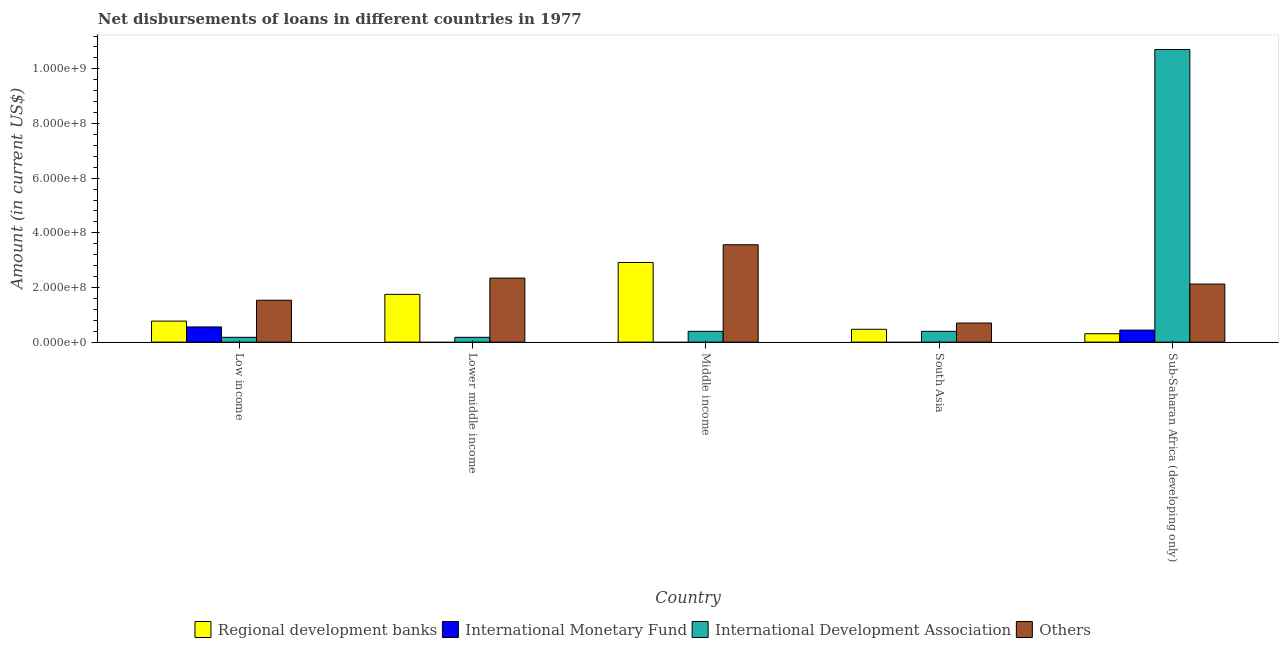How many groups of bars are there?
Provide a succinct answer. 5. Are the number of bars on each tick of the X-axis equal?
Ensure brevity in your answer.  No. What is the label of the 2nd group of bars from the left?
Keep it short and to the point. Lower middle income. What is the amount of loan disimbursed by regional development banks in South Asia?
Offer a very short reply. 4.70e+07. Across all countries, what is the maximum amount of loan disimbursed by international development association?
Offer a terse response. 1.07e+09. What is the total amount of loan disimbursed by regional development banks in the graph?
Offer a terse response. 6.21e+08. What is the difference between the amount of loan disimbursed by regional development banks in Lower middle income and that in South Asia?
Your answer should be compact. 1.28e+08. What is the difference between the amount of loan disimbursed by regional development banks in Lower middle income and the amount of loan disimbursed by international monetary fund in South Asia?
Provide a succinct answer. 1.75e+08. What is the average amount of loan disimbursed by regional development banks per country?
Your response must be concise. 1.24e+08. What is the difference between the amount of loan disimbursed by international development association and amount of loan disimbursed by other organisations in Low income?
Make the answer very short. -1.36e+08. In how many countries, is the amount of loan disimbursed by international development association greater than 1040000000 US$?
Your answer should be very brief. 1. What is the ratio of the amount of loan disimbursed by regional development banks in Lower middle income to that in South Asia?
Make the answer very short. 3.72. Is the amount of loan disimbursed by international development association in Middle income less than that in Sub-Saharan Africa (developing only)?
Provide a short and direct response. Yes. What is the difference between the highest and the second highest amount of loan disimbursed by international development association?
Ensure brevity in your answer.  1.03e+09. What is the difference between the highest and the lowest amount of loan disimbursed by regional development banks?
Make the answer very short. 2.61e+08. Is it the case that in every country, the sum of the amount of loan disimbursed by international development association and amount of loan disimbursed by other organisations is greater than the sum of amount of loan disimbursed by international monetary fund and amount of loan disimbursed by regional development banks?
Keep it short and to the point. No. How many countries are there in the graph?
Offer a terse response. 5. What is the difference between two consecutive major ticks on the Y-axis?
Your answer should be compact. 2.00e+08. Where does the legend appear in the graph?
Your answer should be compact. Bottom center. How many legend labels are there?
Give a very brief answer. 4. What is the title of the graph?
Keep it short and to the point. Net disbursements of loans in different countries in 1977. Does "Coal" appear as one of the legend labels in the graph?
Give a very brief answer. No. What is the Amount (in current US$) in Regional development banks in Low income?
Offer a very short reply. 7.70e+07. What is the Amount (in current US$) of International Monetary Fund in Low income?
Ensure brevity in your answer.  5.57e+07. What is the Amount (in current US$) in International Development Association in Low income?
Ensure brevity in your answer.  1.77e+07. What is the Amount (in current US$) of Others in Low income?
Keep it short and to the point. 1.53e+08. What is the Amount (in current US$) in Regional development banks in Lower middle income?
Your answer should be very brief. 1.75e+08. What is the Amount (in current US$) in International Monetary Fund in Lower middle income?
Your response must be concise. 0. What is the Amount (in current US$) in International Development Association in Lower middle income?
Offer a terse response. 1.77e+07. What is the Amount (in current US$) in Others in Lower middle income?
Ensure brevity in your answer.  2.34e+08. What is the Amount (in current US$) in Regional development banks in Middle income?
Provide a succinct answer. 2.91e+08. What is the Amount (in current US$) of International Development Association in Middle income?
Offer a very short reply. 3.96e+07. What is the Amount (in current US$) in Others in Middle income?
Your answer should be compact. 3.56e+08. What is the Amount (in current US$) of Regional development banks in South Asia?
Your answer should be very brief. 4.70e+07. What is the Amount (in current US$) of International Monetary Fund in South Asia?
Provide a succinct answer. 0. What is the Amount (in current US$) in International Development Association in South Asia?
Your answer should be very brief. 3.96e+07. What is the Amount (in current US$) of Others in South Asia?
Offer a very short reply. 6.99e+07. What is the Amount (in current US$) in Regional development banks in Sub-Saharan Africa (developing only)?
Provide a short and direct response. 3.08e+07. What is the Amount (in current US$) of International Monetary Fund in Sub-Saharan Africa (developing only)?
Your answer should be very brief. 4.41e+07. What is the Amount (in current US$) in International Development Association in Sub-Saharan Africa (developing only)?
Ensure brevity in your answer.  1.07e+09. What is the Amount (in current US$) in Others in Sub-Saharan Africa (developing only)?
Keep it short and to the point. 2.13e+08. Across all countries, what is the maximum Amount (in current US$) in Regional development banks?
Your answer should be compact. 2.91e+08. Across all countries, what is the maximum Amount (in current US$) in International Monetary Fund?
Offer a terse response. 5.57e+07. Across all countries, what is the maximum Amount (in current US$) in International Development Association?
Offer a terse response. 1.07e+09. Across all countries, what is the maximum Amount (in current US$) in Others?
Offer a terse response. 3.56e+08. Across all countries, what is the minimum Amount (in current US$) of Regional development banks?
Keep it short and to the point. 3.08e+07. Across all countries, what is the minimum Amount (in current US$) in International Development Association?
Give a very brief answer. 1.77e+07. Across all countries, what is the minimum Amount (in current US$) in Others?
Make the answer very short. 6.99e+07. What is the total Amount (in current US$) in Regional development banks in the graph?
Your response must be concise. 6.21e+08. What is the total Amount (in current US$) in International Monetary Fund in the graph?
Your answer should be very brief. 9.98e+07. What is the total Amount (in current US$) of International Development Association in the graph?
Offer a terse response. 1.19e+09. What is the total Amount (in current US$) in Others in the graph?
Offer a very short reply. 1.03e+09. What is the difference between the Amount (in current US$) in Regional development banks in Low income and that in Lower middle income?
Your response must be concise. -9.78e+07. What is the difference between the Amount (in current US$) of International Development Association in Low income and that in Lower middle income?
Offer a very short reply. 0. What is the difference between the Amount (in current US$) of Others in Low income and that in Lower middle income?
Offer a very short reply. -8.11e+07. What is the difference between the Amount (in current US$) of Regional development banks in Low income and that in Middle income?
Provide a succinct answer. -2.14e+08. What is the difference between the Amount (in current US$) of International Development Association in Low income and that in Middle income?
Your answer should be very brief. -2.19e+07. What is the difference between the Amount (in current US$) in Others in Low income and that in Middle income?
Provide a short and direct response. -2.03e+08. What is the difference between the Amount (in current US$) of Regional development banks in Low income and that in South Asia?
Ensure brevity in your answer.  3.00e+07. What is the difference between the Amount (in current US$) in International Development Association in Low income and that in South Asia?
Offer a very short reply. -2.19e+07. What is the difference between the Amount (in current US$) in Others in Low income and that in South Asia?
Your response must be concise. 8.34e+07. What is the difference between the Amount (in current US$) in Regional development banks in Low income and that in Sub-Saharan Africa (developing only)?
Give a very brief answer. 4.63e+07. What is the difference between the Amount (in current US$) in International Monetary Fund in Low income and that in Sub-Saharan Africa (developing only)?
Offer a very short reply. 1.16e+07. What is the difference between the Amount (in current US$) of International Development Association in Low income and that in Sub-Saharan Africa (developing only)?
Keep it short and to the point. -1.05e+09. What is the difference between the Amount (in current US$) in Others in Low income and that in Sub-Saharan Africa (developing only)?
Offer a terse response. -5.93e+07. What is the difference between the Amount (in current US$) of Regional development banks in Lower middle income and that in Middle income?
Your response must be concise. -1.17e+08. What is the difference between the Amount (in current US$) in International Development Association in Lower middle income and that in Middle income?
Your answer should be very brief. -2.19e+07. What is the difference between the Amount (in current US$) of Others in Lower middle income and that in Middle income?
Make the answer very short. -1.22e+08. What is the difference between the Amount (in current US$) in Regional development banks in Lower middle income and that in South Asia?
Provide a succinct answer. 1.28e+08. What is the difference between the Amount (in current US$) of International Development Association in Lower middle income and that in South Asia?
Provide a short and direct response. -2.19e+07. What is the difference between the Amount (in current US$) of Others in Lower middle income and that in South Asia?
Your answer should be compact. 1.65e+08. What is the difference between the Amount (in current US$) in Regional development banks in Lower middle income and that in Sub-Saharan Africa (developing only)?
Your answer should be very brief. 1.44e+08. What is the difference between the Amount (in current US$) in International Development Association in Lower middle income and that in Sub-Saharan Africa (developing only)?
Provide a succinct answer. -1.05e+09. What is the difference between the Amount (in current US$) in Others in Lower middle income and that in Sub-Saharan Africa (developing only)?
Keep it short and to the point. 2.18e+07. What is the difference between the Amount (in current US$) of Regional development banks in Middle income and that in South Asia?
Your answer should be compact. 2.44e+08. What is the difference between the Amount (in current US$) in Others in Middle income and that in South Asia?
Your answer should be compact. 2.86e+08. What is the difference between the Amount (in current US$) in Regional development banks in Middle income and that in Sub-Saharan Africa (developing only)?
Give a very brief answer. 2.61e+08. What is the difference between the Amount (in current US$) of International Development Association in Middle income and that in Sub-Saharan Africa (developing only)?
Ensure brevity in your answer.  -1.03e+09. What is the difference between the Amount (in current US$) of Others in Middle income and that in Sub-Saharan Africa (developing only)?
Provide a succinct answer. 1.44e+08. What is the difference between the Amount (in current US$) of Regional development banks in South Asia and that in Sub-Saharan Africa (developing only)?
Give a very brief answer. 1.63e+07. What is the difference between the Amount (in current US$) in International Development Association in South Asia and that in Sub-Saharan Africa (developing only)?
Offer a very short reply. -1.03e+09. What is the difference between the Amount (in current US$) of Others in South Asia and that in Sub-Saharan Africa (developing only)?
Your answer should be very brief. -1.43e+08. What is the difference between the Amount (in current US$) in Regional development banks in Low income and the Amount (in current US$) in International Development Association in Lower middle income?
Your answer should be compact. 5.93e+07. What is the difference between the Amount (in current US$) of Regional development banks in Low income and the Amount (in current US$) of Others in Lower middle income?
Offer a terse response. -1.57e+08. What is the difference between the Amount (in current US$) of International Monetary Fund in Low income and the Amount (in current US$) of International Development Association in Lower middle income?
Give a very brief answer. 3.80e+07. What is the difference between the Amount (in current US$) in International Monetary Fund in Low income and the Amount (in current US$) in Others in Lower middle income?
Keep it short and to the point. -1.79e+08. What is the difference between the Amount (in current US$) in International Development Association in Low income and the Amount (in current US$) in Others in Lower middle income?
Make the answer very short. -2.17e+08. What is the difference between the Amount (in current US$) of Regional development banks in Low income and the Amount (in current US$) of International Development Association in Middle income?
Ensure brevity in your answer.  3.75e+07. What is the difference between the Amount (in current US$) of Regional development banks in Low income and the Amount (in current US$) of Others in Middle income?
Ensure brevity in your answer.  -2.79e+08. What is the difference between the Amount (in current US$) in International Monetary Fund in Low income and the Amount (in current US$) in International Development Association in Middle income?
Your answer should be very brief. 1.61e+07. What is the difference between the Amount (in current US$) in International Monetary Fund in Low income and the Amount (in current US$) in Others in Middle income?
Ensure brevity in your answer.  -3.01e+08. What is the difference between the Amount (in current US$) of International Development Association in Low income and the Amount (in current US$) of Others in Middle income?
Your response must be concise. -3.39e+08. What is the difference between the Amount (in current US$) of Regional development banks in Low income and the Amount (in current US$) of International Development Association in South Asia?
Provide a succinct answer. 3.75e+07. What is the difference between the Amount (in current US$) of Regional development banks in Low income and the Amount (in current US$) of Others in South Asia?
Provide a short and direct response. 7.12e+06. What is the difference between the Amount (in current US$) of International Monetary Fund in Low income and the Amount (in current US$) of International Development Association in South Asia?
Make the answer very short. 1.61e+07. What is the difference between the Amount (in current US$) of International Monetary Fund in Low income and the Amount (in current US$) of Others in South Asia?
Keep it short and to the point. -1.42e+07. What is the difference between the Amount (in current US$) of International Development Association in Low income and the Amount (in current US$) of Others in South Asia?
Make the answer very short. -5.22e+07. What is the difference between the Amount (in current US$) of Regional development banks in Low income and the Amount (in current US$) of International Monetary Fund in Sub-Saharan Africa (developing only)?
Your answer should be compact. 3.29e+07. What is the difference between the Amount (in current US$) in Regional development banks in Low income and the Amount (in current US$) in International Development Association in Sub-Saharan Africa (developing only)?
Your answer should be compact. -9.94e+08. What is the difference between the Amount (in current US$) in Regional development banks in Low income and the Amount (in current US$) in Others in Sub-Saharan Africa (developing only)?
Offer a terse response. -1.36e+08. What is the difference between the Amount (in current US$) in International Monetary Fund in Low income and the Amount (in current US$) in International Development Association in Sub-Saharan Africa (developing only)?
Offer a very short reply. -1.02e+09. What is the difference between the Amount (in current US$) in International Monetary Fund in Low income and the Amount (in current US$) in Others in Sub-Saharan Africa (developing only)?
Make the answer very short. -1.57e+08. What is the difference between the Amount (in current US$) of International Development Association in Low income and the Amount (in current US$) of Others in Sub-Saharan Africa (developing only)?
Your response must be concise. -1.95e+08. What is the difference between the Amount (in current US$) of Regional development banks in Lower middle income and the Amount (in current US$) of International Development Association in Middle income?
Provide a short and direct response. 1.35e+08. What is the difference between the Amount (in current US$) in Regional development banks in Lower middle income and the Amount (in current US$) in Others in Middle income?
Give a very brief answer. -1.81e+08. What is the difference between the Amount (in current US$) in International Development Association in Lower middle income and the Amount (in current US$) in Others in Middle income?
Make the answer very short. -3.39e+08. What is the difference between the Amount (in current US$) in Regional development banks in Lower middle income and the Amount (in current US$) in International Development Association in South Asia?
Provide a short and direct response. 1.35e+08. What is the difference between the Amount (in current US$) in Regional development banks in Lower middle income and the Amount (in current US$) in Others in South Asia?
Make the answer very short. 1.05e+08. What is the difference between the Amount (in current US$) in International Development Association in Lower middle income and the Amount (in current US$) in Others in South Asia?
Provide a succinct answer. -5.22e+07. What is the difference between the Amount (in current US$) in Regional development banks in Lower middle income and the Amount (in current US$) in International Monetary Fund in Sub-Saharan Africa (developing only)?
Your response must be concise. 1.31e+08. What is the difference between the Amount (in current US$) of Regional development banks in Lower middle income and the Amount (in current US$) of International Development Association in Sub-Saharan Africa (developing only)?
Your answer should be very brief. -8.96e+08. What is the difference between the Amount (in current US$) in Regional development banks in Lower middle income and the Amount (in current US$) in Others in Sub-Saharan Africa (developing only)?
Ensure brevity in your answer.  -3.78e+07. What is the difference between the Amount (in current US$) of International Development Association in Lower middle income and the Amount (in current US$) of Others in Sub-Saharan Africa (developing only)?
Your answer should be compact. -1.95e+08. What is the difference between the Amount (in current US$) of Regional development banks in Middle income and the Amount (in current US$) of International Development Association in South Asia?
Ensure brevity in your answer.  2.52e+08. What is the difference between the Amount (in current US$) of Regional development banks in Middle income and the Amount (in current US$) of Others in South Asia?
Your answer should be compact. 2.22e+08. What is the difference between the Amount (in current US$) in International Development Association in Middle income and the Amount (in current US$) in Others in South Asia?
Your answer should be compact. -3.03e+07. What is the difference between the Amount (in current US$) in Regional development banks in Middle income and the Amount (in current US$) in International Monetary Fund in Sub-Saharan Africa (developing only)?
Your answer should be very brief. 2.47e+08. What is the difference between the Amount (in current US$) of Regional development banks in Middle income and the Amount (in current US$) of International Development Association in Sub-Saharan Africa (developing only)?
Provide a succinct answer. -7.79e+08. What is the difference between the Amount (in current US$) of Regional development banks in Middle income and the Amount (in current US$) of Others in Sub-Saharan Africa (developing only)?
Provide a short and direct response. 7.88e+07. What is the difference between the Amount (in current US$) of International Development Association in Middle income and the Amount (in current US$) of Others in Sub-Saharan Africa (developing only)?
Give a very brief answer. -1.73e+08. What is the difference between the Amount (in current US$) in Regional development banks in South Asia and the Amount (in current US$) in International Monetary Fund in Sub-Saharan Africa (developing only)?
Ensure brevity in your answer.  2.94e+06. What is the difference between the Amount (in current US$) in Regional development banks in South Asia and the Amount (in current US$) in International Development Association in Sub-Saharan Africa (developing only)?
Your response must be concise. -1.02e+09. What is the difference between the Amount (in current US$) of Regional development banks in South Asia and the Amount (in current US$) of Others in Sub-Saharan Africa (developing only)?
Your response must be concise. -1.66e+08. What is the difference between the Amount (in current US$) in International Development Association in South Asia and the Amount (in current US$) in Others in Sub-Saharan Africa (developing only)?
Your response must be concise. -1.73e+08. What is the average Amount (in current US$) in Regional development banks per country?
Your response must be concise. 1.24e+08. What is the average Amount (in current US$) in International Monetary Fund per country?
Keep it short and to the point. 2.00e+07. What is the average Amount (in current US$) in International Development Association per country?
Offer a very short reply. 2.37e+08. What is the average Amount (in current US$) in Others per country?
Provide a succinct answer. 2.05e+08. What is the difference between the Amount (in current US$) in Regional development banks and Amount (in current US$) in International Monetary Fund in Low income?
Ensure brevity in your answer.  2.13e+07. What is the difference between the Amount (in current US$) in Regional development banks and Amount (in current US$) in International Development Association in Low income?
Offer a very short reply. 5.93e+07. What is the difference between the Amount (in current US$) in Regional development banks and Amount (in current US$) in Others in Low income?
Your answer should be very brief. -7.63e+07. What is the difference between the Amount (in current US$) in International Monetary Fund and Amount (in current US$) in International Development Association in Low income?
Offer a very short reply. 3.80e+07. What is the difference between the Amount (in current US$) of International Monetary Fund and Amount (in current US$) of Others in Low income?
Offer a very short reply. -9.76e+07. What is the difference between the Amount (in current US$) of International Development Association and Amount (in current US$) of Others in Low income?
Your answer should be very brief. -1.36e+08. What is the difference between the Amount (in current US$) of Regional development banks and Amount (in current US$) of International Development Association in Lower middle income?
Offer a terse response. 1.57e+08. What is the difference between the Amount (in current US$) in Regional development banks and Amount (in current US$) in Others in Lower middle income?
Offer a very short reply. -5.96e+07. What is the difference between the Amount (in current US$) in International Development Association and Amount (in current US$) in Others in Lower middle income?
Give a very brief answer. -2.17e+08. What is the difference between the Amount (in current US$) of Regional development banks and Amount (in current US$) of International Development Association in Middle income?
Ensure brevity in your answer.  2.52e+08. What is the difference between the Amount (in current US$) in Regional development banks and Amount (in current US$) in Others in Middle income?
Your response must be concise. -6.48e+07. What is the difference between the Amount (in current US$) in International Development Association and Amount (in current US$) in Others in Middle income?
Make the answer very short. -3.17e+08. What is the difference between the Amount (in current US$) in Regional development banks and Amount (in current US$) in International Development Association in South Asia?
Your answer should be compact. 7.49e+06. What is the difference between the Amount (in current US$) of Regional development banks and Amount (in current US$) of Others in South Asia?
Make the answer very short. -2.29e+07. What is the difference between the Amount (in current US$) of International Development Association and Amount (in current US$) of Others in South Asia?
Provide a short and direct response. -3.03e+07. What is the difference between the Amount (in current US$) of Regional development banks and Amount (in current US$) of International Monetary Fund in Sub-Saharan Africa (developing only)?
Keep it short and to the point. -1.34e+07. What is the difference between the Amount (in current US$) of Regional development banks and Amount (in current US$) of International Development Association in Sub-Saharan Africa (developing only)?
Your answer should be very brief. -1.04e+09. What is the difference between the Amount (in current US$) in Regional development banks and Amount (in current US$) in Others in Sub-Saharan Africa (developing only)?
Offer a very short reply. -1.82e+08. What is the difference between the Amount (in current US$) of International Monetary Fund and Amount (in current US$) of International Development Association in Sub-Saharan Africa (developing only)?
Offer a very short reply. -1.03e+09. What is the difference between the Amount (in current US$) in International Monetary Fund and Amount (in current US$) in Others in Sub-Saharan Africa (developing only)?
Provide a short and direct response. -1.69e+08. What is the difference between the Amount (in current US$) of International Development Association and Amount (in current US$) of Others in Sub-Saharan Africa (developing only)?
Keep it short and to the point. 8.58e+08. What is the ratio of the Amount (in current US$) in Regional development banks in Low income to that in Lower middle income?
Offer a very short reply. 0.44. What is the ratio of the Amount (in current US$) of International Development Association in Low income to that in Lower middle income?
Offer a terse response. 1. What is the ratio of the Amount (in current US$) in Others in Low income to that in Lower middle income?
Offer a very short reply. 0.65. What is the ratio of the Amount (in current US$) in Regional development banks in Low income to that in Middle income?
Provide a succinct answer. 0.26. What is the ratio of the Amount (in current US$) of International Development Association in Low income to that in Middle income?
Your answer should be very brief. 0.45. What is the ratio of the Amount (in current US$) in Others in Low income to that in Middle income?
Your answer should be very brief. 0.43. What is the ratio of the Amount (in current US$) of Regional development banks in Low income to that in South Asia?
Your answer should be compact. 1.64. What is the ratio of the Amount (in current US$) in International Development Association in Low income to that in South Asia?
Offer a very short reply. 0.45. What is the ratio of the Amount (in current US$) in Others in Low income to that in South Asia?
Make the answer very short. 2.19. What is the ratio of the Amount (in current US$) of Regional development banks in Low income to that in Sub-Saharan Africa (developing only)?
Ensure brevity in your answer.  2.5. What is the ratio of the Amount (in current US$) in International Monetary Fund in Low income to that in Sub-Saharan Africa (developing only)?
Offer a very short reply. 1.26. What is the ratio of the Amount (in current US$) in International Development Association in Low income to that in Sub-Saharan Africa (developing only)?
Keep it short and to the point. 0.02. What is the ratio of the Amount (in current US$) of Others in Low income to that in Sub-Saharan Africa (developing only)?
Your answer should be compact. 0.72. What is the ratio of the Amount (in current US$) of Regional development banks in Lower middle income to that in Middle income?
Offer a terse response. 0.6. What is the ratio of the Amount (in current US$) of International Development Association in Lower middle income to that in Middle income?
Provide a succinct answer. 0.45. What is the ratio of the Amount (in current US$) in Others in Lower middle income to that in Middle income?
Your answer should be compact. 0.66. What is the ratio of the Amount (in current US$) of Regional development banks in Lower middle income to that in South Asia?
Your answer should be compact. 3.72. What is the ratio of the Amount (in current US$) of International Development Association in Lower middle income to that in South Asia?
Offer a terse response. 0.45. What is the ratio of the Amount (in current US$) in Others in Lower middle income to that in South Asia?
Keep it short and to the point. 3.35. What is the ratio of the Amount (in current US$) of Regional development banks in Lower middle income to that in Sub-Saharan Africa (developing only)?
Offer a very short reply. 5.68. What is the ratio of the Amount (in current US$) in International Development Association in Lower middle income to that in Sub-Saharan Africa (developing only)?
Offer a very short reply. 0.02. What is the ratio of the Amount (in current US$) in Others in Lower middle income to that in Sub-Saharan Africa (developing only)?
Provide a succinct answer. 1.1. What is the ratio of the Amount (in current US$) of Regional development banks in Middle income to that in South Asia?
Offer a very short reply. 6.2. What is the ratio of the Amount (in current US$) of International Development Association in Middle income to that in South Asia?
Provide a short and direct response. 1. What is the ratio of the Amount (in current US$) in Others in Middle income to that in South Asia?
Provide a succinct answer. 5.1. What is the ratio of the Amount (in current US$) of Regional development banks in Middle income to that in Sub-Saharan Africa (developing only)?
Offer a terse response. 9.48. What is the ratio of the Amount (in current US$) of International Development Association in Middle income to that in Sub-Saharan Africa (developing only)?
Your answer should be compact. 0.04. What is the ratio of the Amount (in current US$) of Others in Middle income to that in Sub-Saharan Africa (developing only)?
Your response must be concise. 1.68. What is the ratio of the Amount (in current US$) of Regional development banks in South Asia to that in Sub-Saharan Africa (developing only)?
Ensure brevity in your answer.  1.53. What is the ratio of the Amount (in current US$) of International Development Association in South Asia to that in Sub-Saharan Africa (developing only)?
Keep it short and to the point. 0.04. What is the ratio of the Amount (in current US$) in Others in South Asia to that in Sub-Saharan Africa (developing only)?
Your answer should be compact. 0.33. What is the difference between the highest and the second highest Amount (in current US$) of Regional development banks?
Keep it short and to the point. 1.17e+08. What is the difference between the highest and the second highest Amount (in current US$) of International Development Association?
Your answer should be very brief. 1.03e+09. What is the difference between the highest and the second highest Amount (in current US$) of Others?
Your answer should be compact. 1.22e+08. What is the difference between the highest and the lowest Amount (in current US$) in Regional development banks?
Provide a short and direct response. 2.61e+08. What is the difference between the highest and the lowest Amount (in current US$) in International Monetary Fund?
Your response must be concise. 5.57e+07. What is the difference between the highest and the lowest Amount (in current US$) of International Development Association?
Ensure brevity in your answer.  1.05e+09. What is the difference between the highest and the lowest Amount (in current US$) in Others?
Offer a terse response. 2.86e+08. 